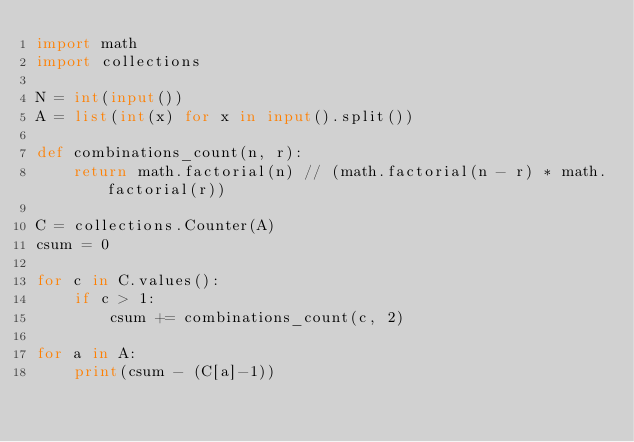<code> <loc_0><loc_0><loc_500><loc_500><_Python_>import math
import collections

N = int(input())
A = list(int(x) for x in input().split())

def combinations_count(n, r):
    return math.factorial(n) // (math.factorial(n - r) * math.factorial(r))

C = collections.Counter(A)
csum = 0

for c in C.values():
    if c > 1:
        csum += combinations_count(c, 2)

for a in A:
    print(csum - (C[a]-1))</code> 